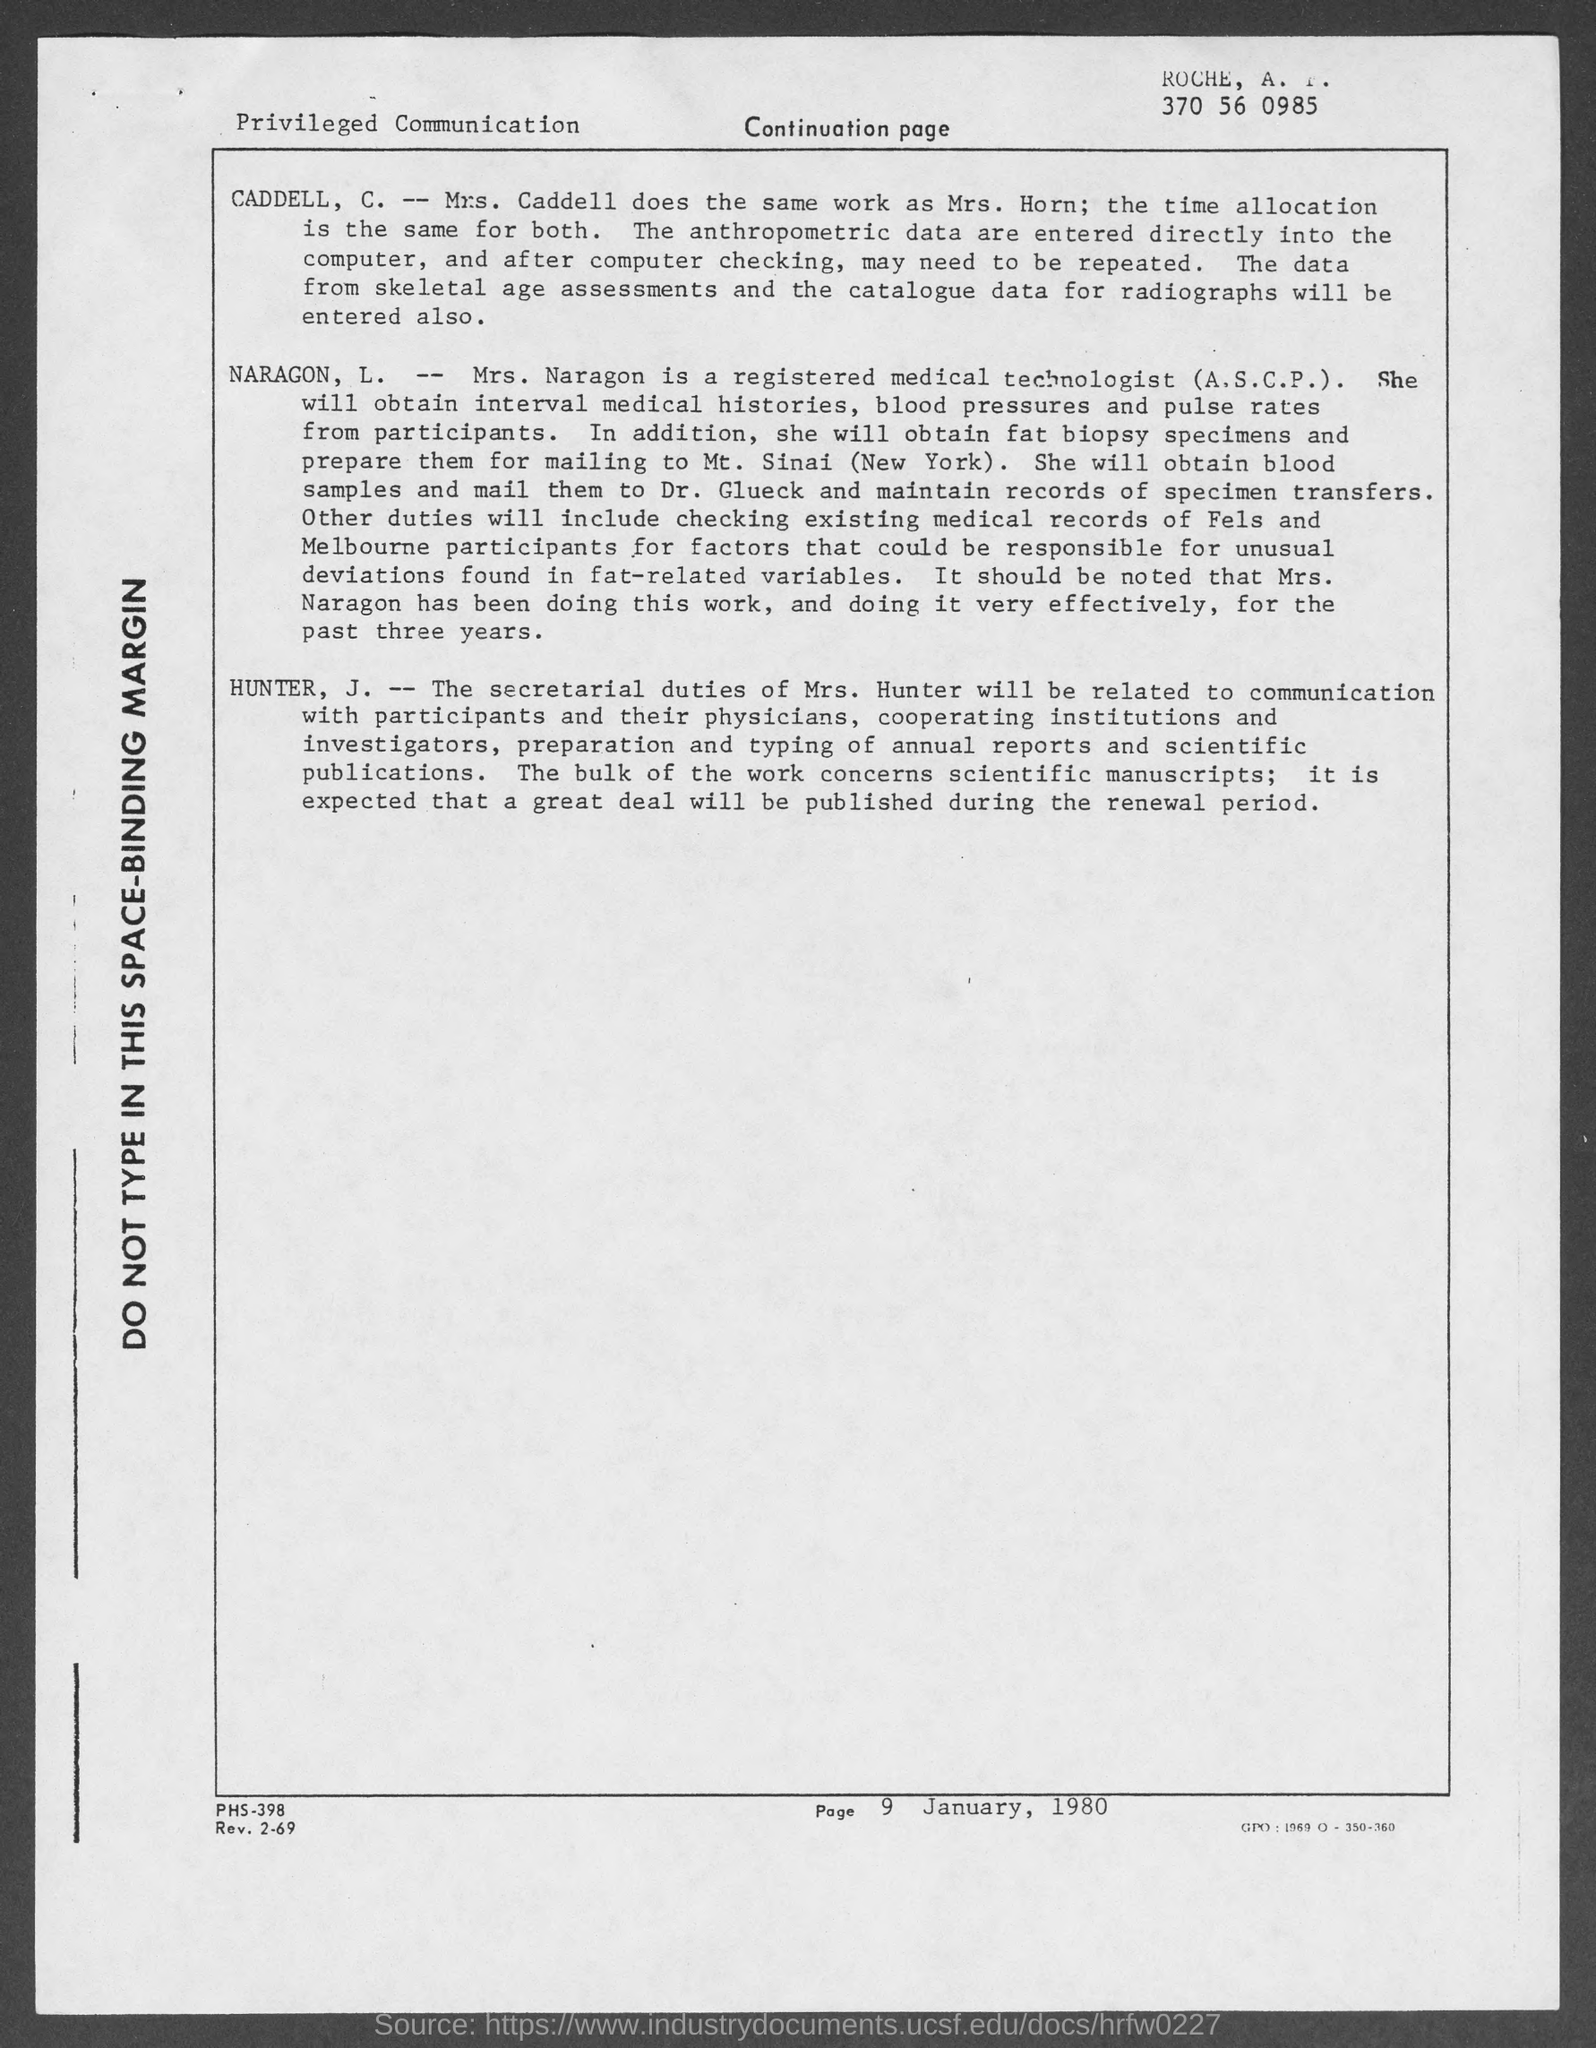Who is Mrs. Naragon, L.?
Your response must be concise. Registered medical technologist (a.s.c.p). 